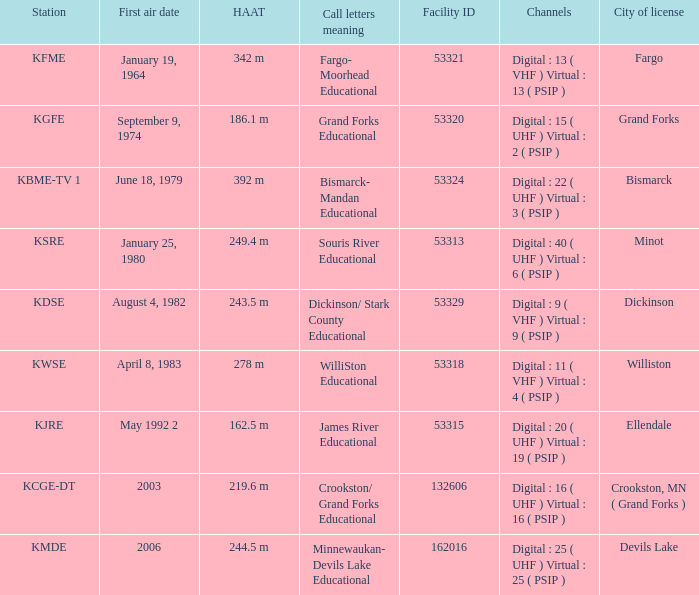What is the haat of devils lake 244.5 m. 